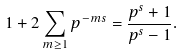Convert formula to latex. <formula><loc_0><loc_0><loc_500><loc_500>1 + 2 \sum _ { m \geq 1 } p ^ { - m s } = \frac { p ^ { s } + 1 } { p ^ { s } - 1 } .</formula> 